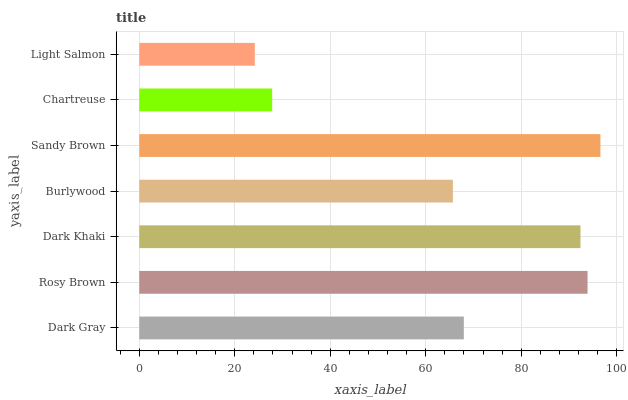Is Light Salmon the minimum?
Answer yes or no. Yes. Is Sandy Brown the maximum?
Answer yes or no. Yes. Is Rosy Brown the minimum?
Answer yes or no. No. Is Rosy Brown the maximum?
Answer yes or no. No. Is Rosy Brown greater than Dark Gray?
Answer yes or no. Yes. Is Dark Gray less than Rosy Brown?
Answer yes or no. Yes. Is Dark Gray greater than Rosy Brown?
Answer yes or no. No. Is Rosy Brown less than Dark Gray?
Answer yes or no. No. Is Dark Gray the high median?
Answer yes or no. Yes. Is Dark Gray the low median?
Answer yes or no. Yes. Is Light Salmon the high median?
Answer yes or no. No. Is Burlywood the low median?
Answer yes or no. No. 